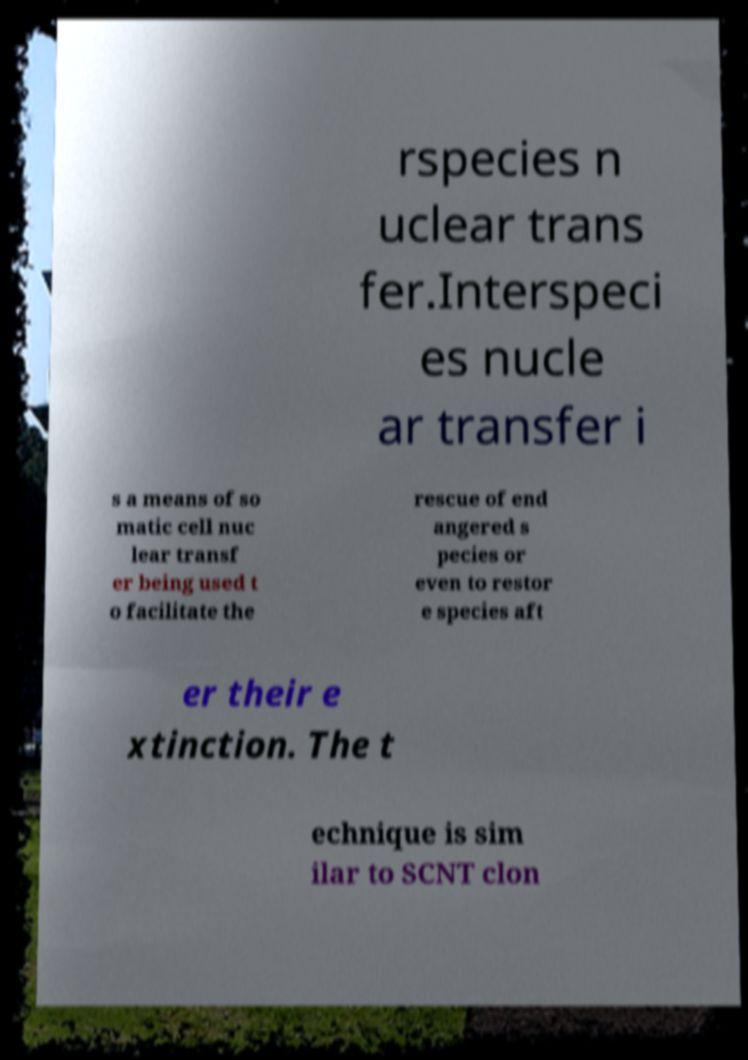What messages or text are displayed in this image? I need them in a readable, typed format. rspecies n uclear trans fer.Interspeci es nucle ar transfer i s a means of so matic cell nuc lear transf er being used t o facilitate the rescue of end angered s pecies or even to restor e species aft er their e xtinction. The t echnique is sim ilar to SCNT clon 